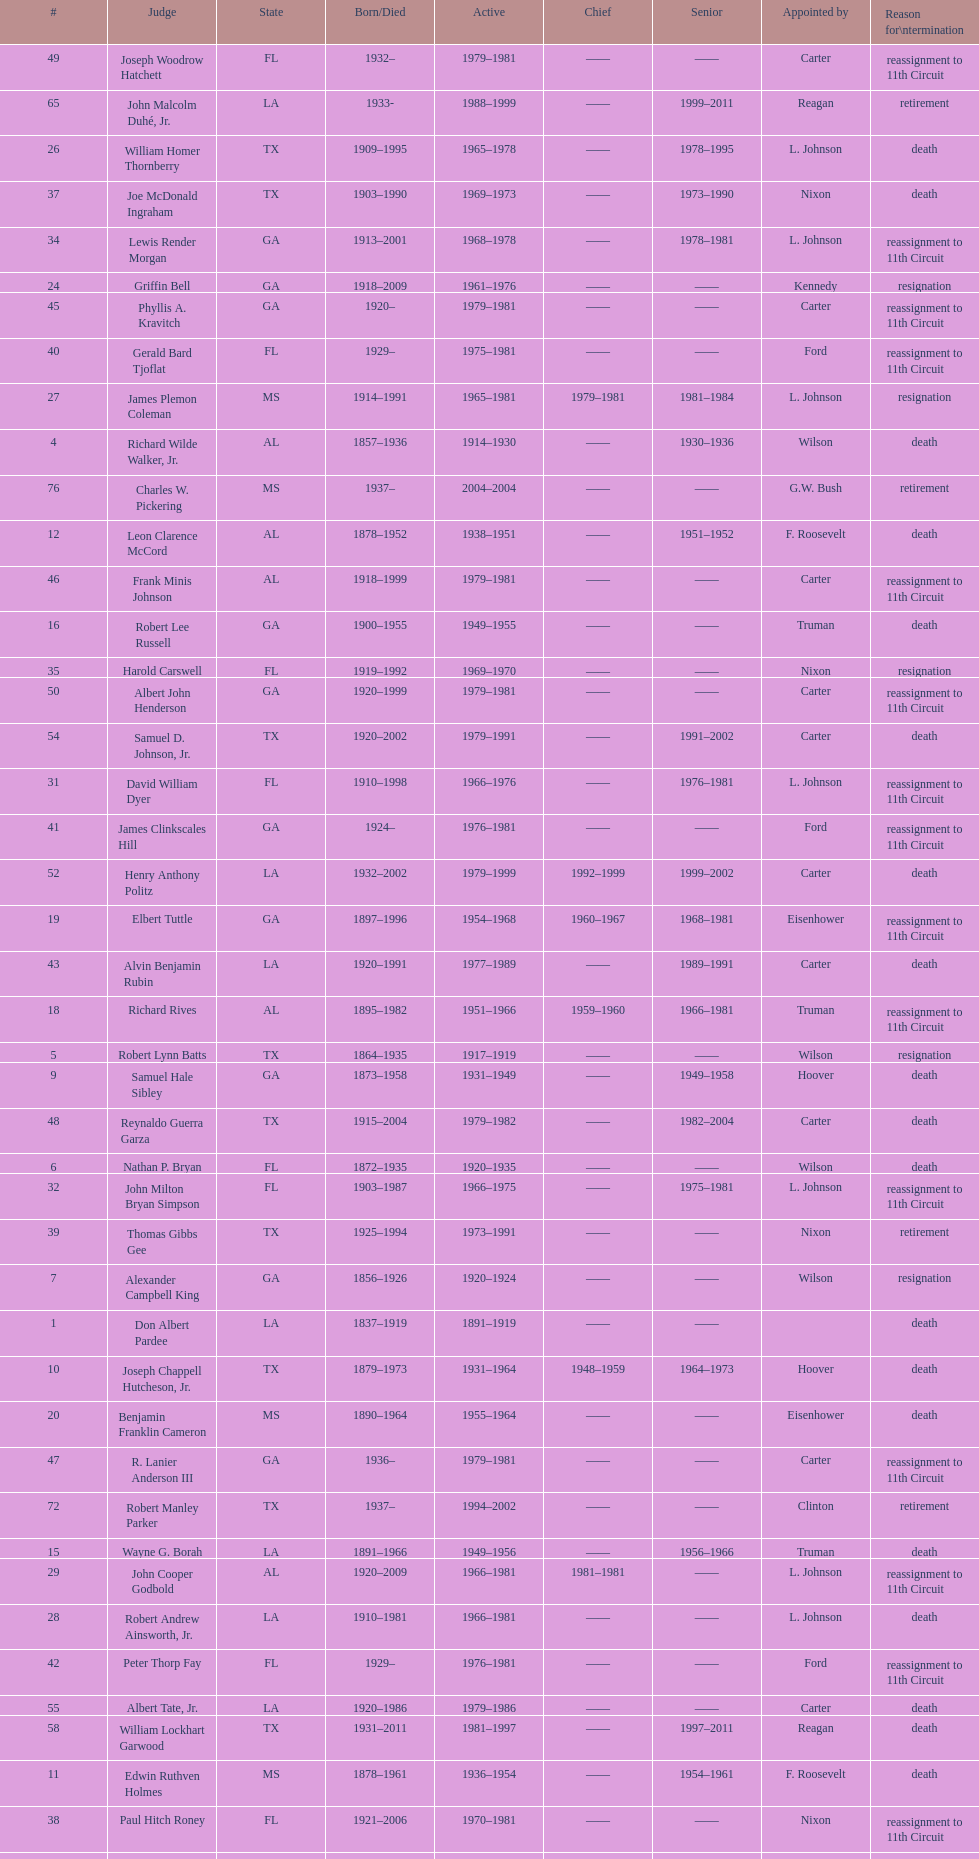Which state has the largest amount of judges to serve? TX. 